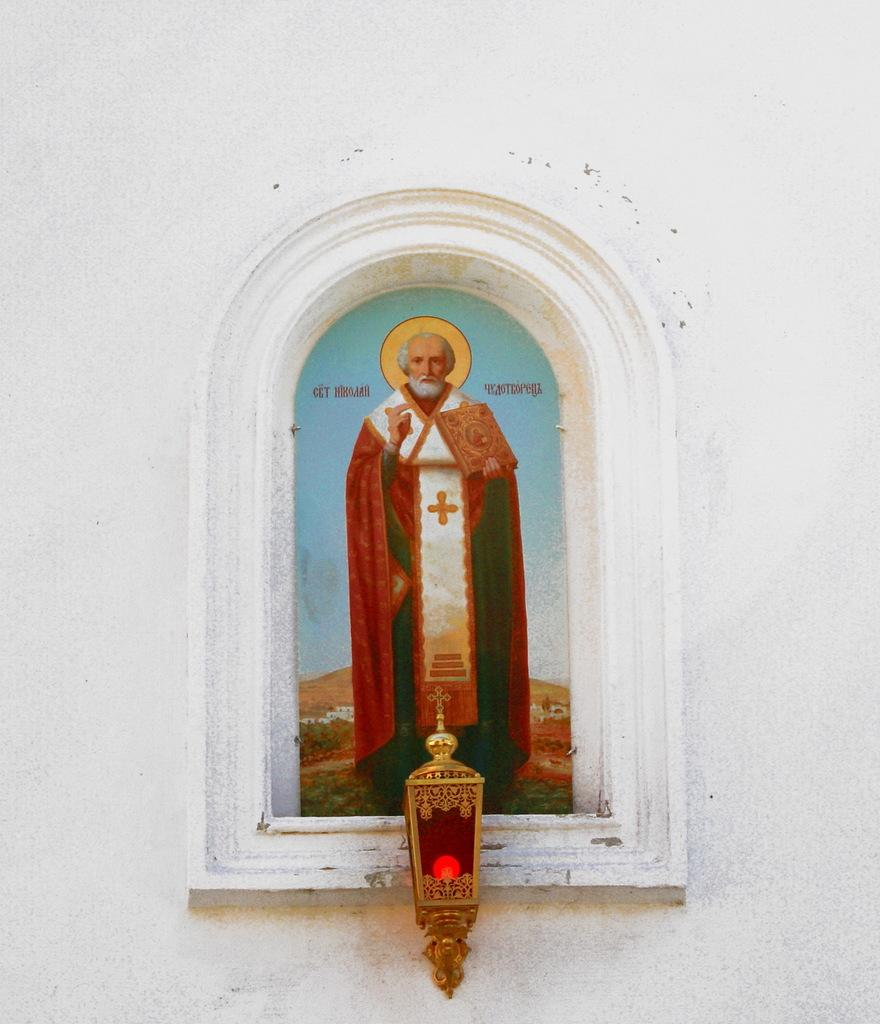What is the main subject of the image? There is a person standing in the image. What is the person wearing? The person is wearing a dress with a cross symbol. Can you describe the dress in more detail? The dress has different colors. What can be seen in front of the person? There is a red bulb and a white wall in front of the person. What type of rhythm does the person in the image have? The image does not provide any information about the person's rhythm, as it focuses on their attire and the objects in front of them. 